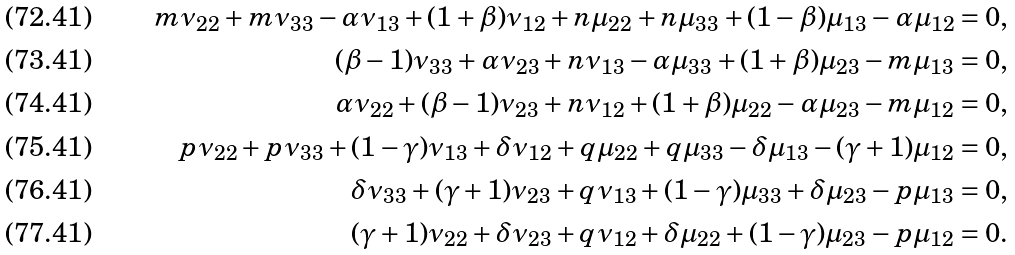<formula> <loc_0><loc_0><loc_500><loc_500>m \nu _ { 2 2 } + m \nu _ { 3 3 } - \alpha \nu _ { 1 3 } + ( 1 + \beta ) \nu _ { 1 2 } + n \mu _ { 2 2 } + n \mu _ { 3 3 } + ( 1 - \beta ) \mu _ { 1 3 } - \alpha \mu _ { 1 2 } = 0 , \\ ( \beta - 1 ) \nu _ { 3 3 } + \alpha \nu _ { 2 3 } + n \nu _ { 1 3 } - \alpha \mu _ { 3 3 } + ( 1 + \beta ) \mu _ { 2 3 } - m \mu _ { 1 3 } = 0 , \\ \alpha \nu _ { 2 2 } + ( \beta - 1 ) \nu _ { 2 3 } + n \nu _ { 1 2 } + ( 1 + \beta ) \mu _ { 2 2 } - \alpha \mu _ { 2 3 } - m \mu _ { 1 2 } = 0 , \\ p \nu _ { 2 2 } + p \nu _ { 3 3 } + ( 1 - \gamma ) \nu _ { 1 3 } + \delta \nu _ { 1 2 } + q \mu _ { 2 2 } + q \mu _ { 3 3 } - \delta \mu _ { 1 3 } - ( \gamma + 1 ) \mu _ { 1 2 } = 0 , \\ \delta \nu _ { 3 3 } + ( \gamma + 1 ) \nu _ { 2 3 } + q \nu _ { 1 3 } + ( 1 - \gamma ) \mu _ { 3 3 } + \delta \mu _ { 2 3 } - p \mu _ { 1 3 } = 0 , \\ ( \gamma + 1 ) \nu _ { 2 2 } + \delta \nu _ { 2 3 } + q \nu _ { 1 2 } + \delta \mu _ { 2 2 } + ( 1 - \gamma ) \mu _ { 2 3 } - p \mu _ { 1 2 } = 0 .</formula> 